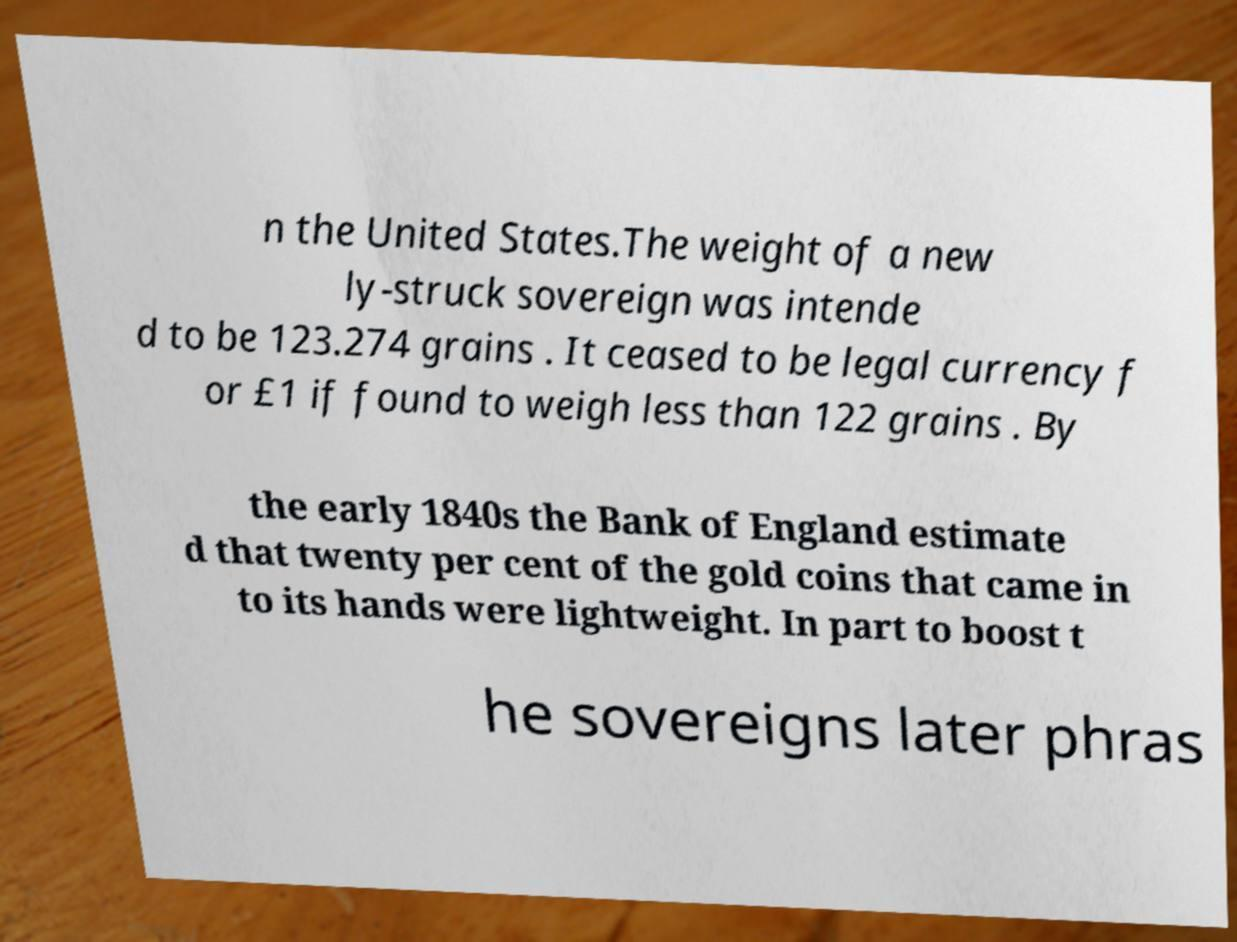Can you read and provide the text displayed in the image?This photo seems to have some interesting text. Can you extract and type it out for me? n the United States.The weight of a new ly-struck sovereign was intende d to be 123.274 grains . It ceased to be legal currency f or £1 if found to weigh less than 122 grains . By the early 1840s the Bank of England estimate d that twenty per cent of the gold coins that came in to its hands were lightweight. In part to boost t he sovereigns later phras 